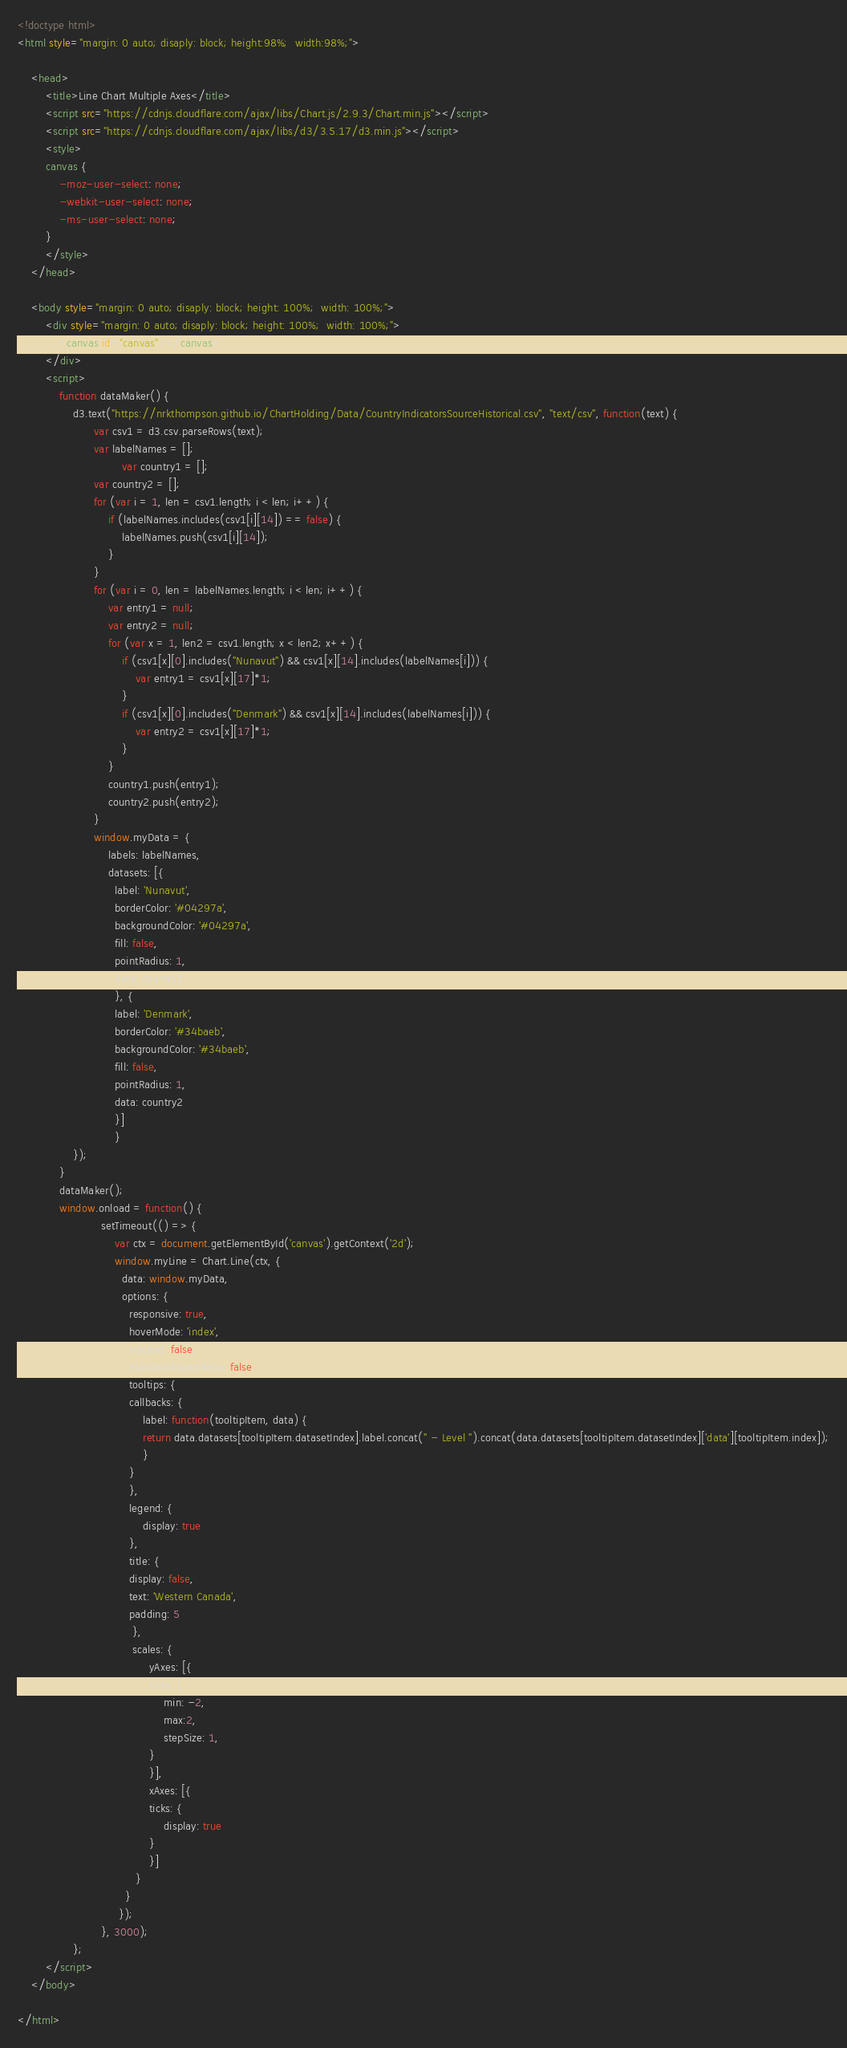<code> <loc_0><loc_0><loc_500><loc_500><_HTML_>
<!doctype html>
<html style="margin: 0 auto; disaply: block; height:98%;  width:98%;">

	<head>
		<title>Line Chart Multiple Axes</title>
		<script src="https://cdnjs.cloudflare.com/ajax/libs/Chart.js/2.9.3/Chart.min.js"></script>
		<script src="https://cdnjs.cloudflare.com/ajax/libs/d3/3.5.17/d3.min.js"></script>
		<style>
		canvas {
			-moz-user-select: none;
			-webkit-user-select: none;
			-ms-user-select: none;
		}
		</style>
	</head>

	<body style="margin: 0 auto; disaply: block; height: 100%;  width: 100%;">
		<div style="margin: 0 auto; disaply: block; height: 100%;  width: 100%;">
			<canvas id="canvas"></canvas>
		</div>
		<script>
			function dataMaker() {
				d3.text("https://nrkthompson.github.io/ChartHolding/Data/CountryIndicatorsSourceHistorical.csv", "text/csv", function(text) {
					  var csv1 = d3.csv.parseRows(text);
					  var labelNames = [];
            				  var country1 = [];
					  var country2 = [];
					  for (var i = 1, len = csv1.length; i < len; i++) {
						  if (labelNames.includes(csv1[i][14]) == false) {
							  labelNames.push(csv1[i][14]);
						  }
					  }
					  for (var i = 0, len = labelNames.length; i < len; i++) {
						  var entry1 = null;
						  var entry2 = null;
						  for (var x = 1, len2 = csv1.length; x < len2; x++) {
							  if (csv1[x][0].includes("Nunavut") && csv1[x][14].includes(labelNames[i])) {
								  var entry1 = csv1[x][17]*1;
							  }
							  if (csv1[x][0].includes("Denmark") && csv1[x][14].includes(labelNames[i])) {
								  var entry2 = csv1[x][17]*1;
							  }
						  }
						  country1.push(entry1);
						  country2.push(entry2);
					  }
					  window.myData = {
						  labels: labelNames,
						  datasets: [{
						    label: 'Nunavut',
						    borderColor: '#04297a',
						    backgroundColor: '#04297a',
						    fill: false,
						    pointRadius: 1,
						    data: country1
						    }, {
						    label: 'Denmark',
						    borderColor: '#34baeb',
						    backgroundColor: '#34baeb',
						    fill: false,
						    pointRadius: 1,
						    data: country2
						    }]
						    }  
				});
			}
			dataMaker();
			window.onload = function() {
						setTimeout(() => { 
							var ctx = document.getElementById('canvas').getContext('2d');
							window.myLine = Chart.Line(ctx, {
							  data: window.myData,
							  options: {
							    responsive: true,
							    hoverMode: 'index',
							    stacked: false,
							    maintainAspectRatio: false,
							    tooltips: {
								callbacks: {
								    label: function(tooltipItem, data) {
									return data.datasets[tooltipItem.datasetIndex].label.concat(" - Level ").concat(data.datasets[tooltipItem.datasetIndex]['data'][tooltipItem.index]);
								    }
								}
							    },
							    legend: {
								    display: true
							    },
							    title: {
								display: false,
								text: 'Western Canada',
								padding: 5
							     },
							     scales: {
								      yAxes: [{
									  ticks: {
									      min: -2,
									      max:2,
									      stepSize: 1,
									  }
								      }],
								      xAxes: [{
									  ticks: {
									      display: true
									  }
								      }]
								  }
							   }
							 });
						}, 3000);
				};
		</script>
	</body>

</html></code> 